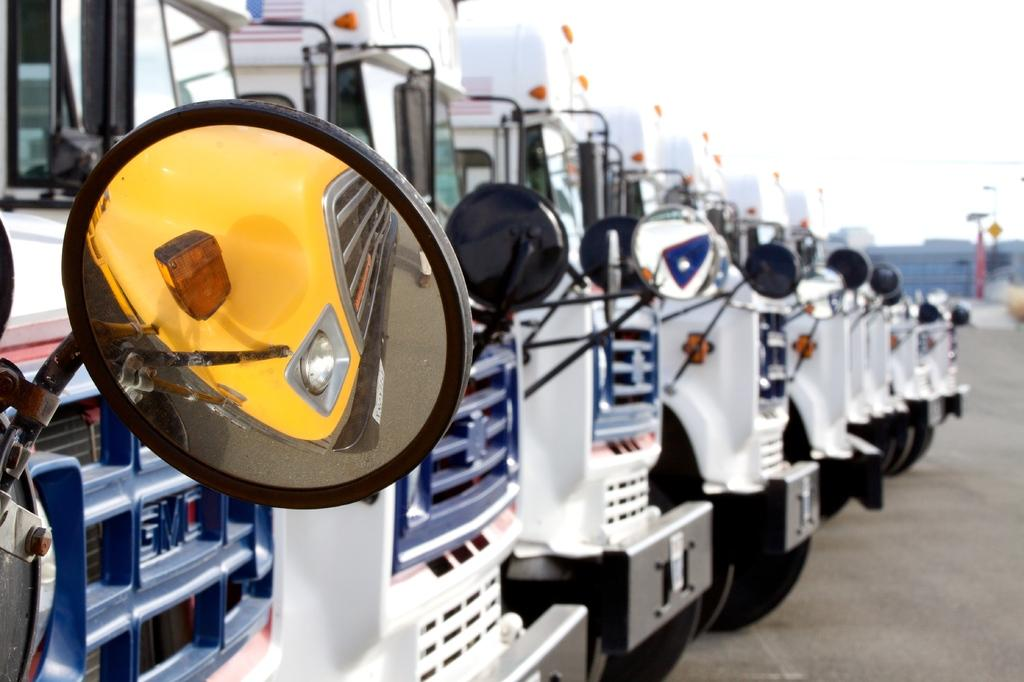What type of vehicles are present in the image? There are buses with side mirrors in the image. Where are the buses located? The buses are on the ground. What can be seen in the background of the image? There are buildings visible in the background of the image, although they appear blurry. What type of cushion is used for the buses' seats in the image? There is no information about the buses' seats or the cushions used in the image. 